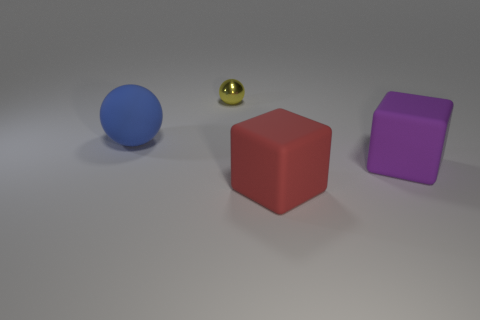The large rubber sphere has what color?
Your answer should be very brief. Blue. There is a matte object left of the yellow object; does it have the same size as the sphere that is behind the big blue thing?
Offer a very short reply. No. Is the number of big rubber cubes less than the number of objects?
Your response must be concise. Yes. There is a large red thing; how many big purple objects are in front of it?
Offer a very short reply. 0. What is the material of the large red cube?
Offer a very short reply. Rubber. Is the number of matte objects behind the big blue matte thing less than the number of brown matte things?
Your response must be concise. No. What is the color of the big block to the right of the red rubber block?
Offer a terse response. Purple. What shape is the yellow object?
Provide a short and direct response. Sphere. There is a thing on the right side of the big red rubber cube right of the metallic ball; is there a purple object that is to the left of it?
Offer a very short reply. No. What is the color of the matte cube to the left of the big matte block that is behind the cube to the left of the purple block?
Offer a very short reply. Red. 